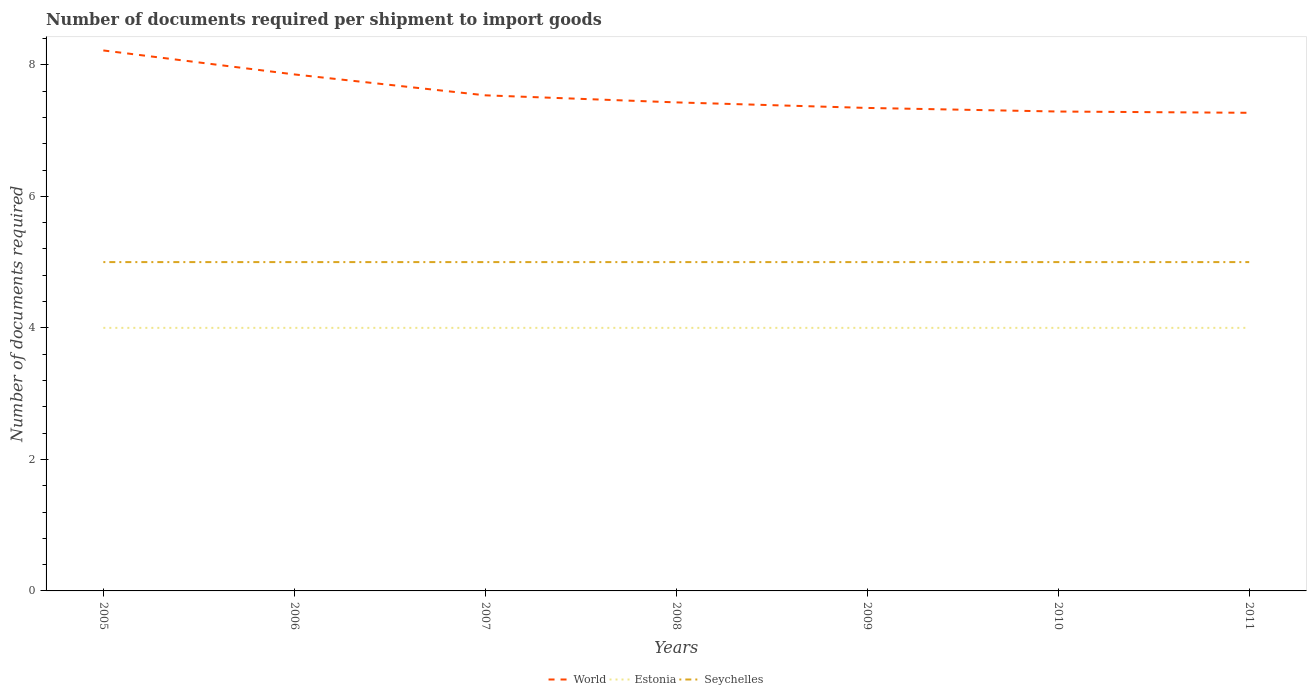How many different coloured lines are there?
Provide a short and direct response. 3. Is the number of lines equal to the number of legend labels?
Your response must be concise. Yes. Across all years, what is the maximum number of documents required per shipment to import goods in World?
Provide a short and direct response. 7.27. What is the difference between the highest and the second highest number of documents required per shipment to import goods in Estonia?
Your answer should be compact. 0. Is the number of documents required per shipment to import goods in World strictly greater than the number of documents required per shipment to import goods in Estonia over the years?
Provide a short and direct response. No. How many lines are there?
Provide a succinct answer. 3. Are the values on the major ticks of Y-axis written in scientific E-notation?
Give a very brief answer. No. Does the graph contain grids?
Keep it short and to the point. No. Where does the legend appear in the graph?
Give a very brief answer. Bottom center. How are the legend labels stacked?
Provide a short and direct response. Horizontal. What is the title of the graph?
Provide a short and direct response. Number of documents required per shipment to import goods. What is the label or title of the Y-axis?
Your response must be concise. Number of documents required. What is the Number of documents required of World in 2005?
Your response must be concise. 8.22. What is the Number of documents required in Estonia in 2005?
Keep it short and to the point. 4. What is the Number of documents required of World in 2006?
Offer a terse response. 7.85. What is the Number of documents required of Estonia in 2006?
Your answer should be compact. 4. What is the Number of documents required in Seychelles in 2006?
Your response must be concise. 5. What is the Number of documents required of World in 2007?
Your response must be concise. 7.54. What is the Number of documents required of Seychelles in 2007?
Your response must be concise. 5. What is the Number of documents required of World in 2008?
Keep it short and to the point. 7.43. What is the Number of documents required of Seychelles in 2008?
Ensure brevity in your answer.  5. What is the Number of documents required of World in 2009?
Your answer should be compact. 7.34. What is the Number of documents required of Estonia in 2009?
Ensure brevity in your answer.  4. What is the Number of documents required of World in 2010?
Your response must be concise. 7.29. What is the Number of documents required of Estonia in 2010?
Your answer should be very brief. 4. What is the Number of documents required of Seychelles in 2010?
Provide a short and direct response. 5. What is the Number of documents required of World in 2011?
Ensure brevity in your answer.  7.27. What is the Number of documents required in Estonia in 2011?
Your response must be concise. 4. Across all years, what is the maximum Number of documents required in World?
Your response must be concise. 8.22. Across all years, what is the maximum Number of documents required in Estonia?
Provide a short and direct response. 4. Across all years, what is the minimum Number of documents required of World?
Your response must be concise. 7.27. Across all years, what is the minimum Number of documents required of Estonia?
Offer a very short reply. 4. Across all years, what is the minimum Number of documents required of Seychelles?
Your answer should be very brief. 5. What is the total Number of documents required in World in the graph?
Offer a very short reply. 52.94. What is the total Number of documents required of Estonia in the graph?
Your response must be concise. 28. What is the total Number of documents required in Seychelles in the graph?
Your answer should be very brief. 35. What is the difference between the Number of documents required in World in 2005 and that in 2006?
Your answer should be compact. 0.36. What is the difference between the Number of documents required of Estonia in 2005 and that in 2006?
Provide a succinct answer. 0. What is the difference between the Number of documents required of Seychelles in 2005 and that in 2006?
Provide a short and direct response. 0. What is the difference between the Number of documents required of World in 2005 and that in 2007?
Your response must be concise. 0.68. What is the difference between the Number of documents required of Seychelles in 2005 and that in 2007?
Provide a succinct answer. 0. What is the difference between the Number of documents required in World in 2005 and that in 2008?
Offer a terse response. 0.79. What is the difference between the Number of documents required in Seychelles in 2005 and that in 2008?
Offer a terse response. 0. What is the difference between the Number of documents required in World in 2005 and that in 2009?
Give a very brief answer. 0.87. What is the difference between the Number of documents required in Estonia in 2005 and that in 2009?
Give a very brief answer. 0. What is the difference between the Number of documents required of World in 2005 and that in 2010?
Offer a very short reply. 0.93. What is the difference between the Number of documents required in Estonia in 2005 and that in 2010?
Give a very brief answer. 0. What is the difference between the Number of documents required of World in 2005 and that in 2011?
Keep it short and to the point. 0.95. What is the difference between the Number of documents required in Estonia in 2005 and that in 2011?
Ensure brevity in your answer.  0. What is the difference between the Number of documents required in World in 2006 and that in 2007?
Keep it short and to the point. 0.32. What is the difference between the Number of documents required in Estonia in 2006 and that in 2007?
Give a very brief answer. 0. What is the difference between the Number of documents required of World in 2006 and that in 2008?
Your response must be concise. 0.43. What is the difference between the Number of documents required of Estonia in 2006 and that in 2008?
Provide a short and direct response. 0. What is the difference between the Number of documents required of Seychelles in 2006 and that in 2008?
Your answer should be compact. 0. What is the difference between the Number of documents required of World in 2006 and that in 2009?
Ensure brevity in your answer.  0.51. What is the difference between the Number of documents required of Seychelles in 2006 and that in 2009?
Your answer should be very brief. 0. What is the difference between the Number of documents required in World in 2006 and that in 2010?
Make the answer very short. 0.56. What is the difference between the Number of documents required of Estonia in 2006 and that in 2010?
Your answer should be compact. 0. What is the difference between the Number of documents required in Seychelles in 2006 and that in 2010?
Your answer should be compact. 0. What is the difference between the Number of documents required in World in 2006 and that in 2011?
Your answer should be compact. 0.58. What is the difference between the Number of documents required of Seychelles in 2006 and that in 2011?
Offer a very short reply. 0. What is the difference between the Number of documents required in World in 2007 and that in 2008?
Ensure brevity in your answer.  0.11. What is the difference between the Number of documents required of Seychelles in 2007 and that in 2008?
Keep it short and to the point. 0. What is the difference between the Number of documents required in World in 2007 and that in 2009?
Offer a terse response. 0.19. What is the difference between the Number of documents required of World in 2007 and that in 2010?
Make the answer very short. 0.25. What is the difference between the Number of documents required in Estonia in 2007 and that in 2010?
Offer a very short reply. 0. What is the difference between the Number of documents required in World in 2007 and that in 2011?
Make the answer very short. 0.27. What is the difference between the Number of documents required in World in 2008 and that in 2009?
Offer a terse response. 0.08. What is the difference between the Number of documents required in Seychelles in 2008 and that in 2009?
Offer a very short reply. 0. What is the difference between the Number of documents required in World in 2008 and that in 2010?
Give a very brief answer. 0.14. What is the difference between the Number of documents required of Seychelles in 2008 and that in 2010?
Offer a terse response. 0. What is the difference between the Number of documents required in World in 2008 and that in 2011?
Offer a very short reply. 0.16. What is the difference between the Number of documents required in Seychelles in 2008 and that in 2011?
Provide a short and direct response. 0. What is the difference between the Number of documents required of World in 2009 and that in 2010?
Your answer should be very brief. 0.05. What is the difference between the Number of documents required in Seychelles in 2009 and that in 2010?
Give a very brief answer. 0. What is the difference between the Number of documents required of World in 2009 and that in 2011?
Provide a succinct answer. 0.07. What is the difference between the Number of documents required in World in 2010 and that in 2011?
Your answer should be very brief. 0.02. What is the difference between the Number of documents required in Estonia in 2010 and that in 2011?
Offer a very short reply. 0. What is the difference between the Number of documents required in World in 2005 and the Number of documents required in Estonia in 2006?
Offer a very short reply. 4.22. What is the difference between the Number of documents required in World in 2005 and the Number of documents required in Seychelles in 2006?
Your answer should be very brief. 3.22. What is the difference between the Number of documents required in Estonia in 2005 and the Number of documents required in Seychelles in 2006?
Provide a short and direct response. -1. What is the difference between the Number of documents required in World in 2005 and the Number of documents required in Estonia in 2007?
Provide a short and direct response. 4.22. What is the difference between the Number of documents required in World in 2005 and the Number of documents required in Seychelles in 2007?
Make the answer very short. 3.22. What is the difference between the Number of documents required in Estonia in 2005 and the Number of documents required in Seychelles in 2007?
Your answer should be compact. -1. What is the difference between the Number of documents required in World in 2005 and the Number of documents required in Estonia in 2008?
Ensure brevity in your answer.  4.22. What is the difference between the Number of documents required of World in 2005 and the Number of documents required of Seychelles in 2008?
Offer a terse response. 3.22. What is the difference between the Number of documents required in Estonia in 2005 and the Number of documents required in Seychelles in 2008?
Your answer should be very brief. -1. What is the difference between the Number of documents required of World in 2005 and the Number of documents required of Estonia in 2009?
Your answer should be very brief. 4.22. What is the difference between the Number of documents required of World in 2005 and the Number of documents required of Seychelles in 2009?
Your answer should be compact. 3.22. What is the difference between the Number of documents required in Estonia in 2005 and the Number of documents required in Seychelles in 2009?
Give a very brief answer. -1. What is the difference between the Number of documents required of World in 2005 and the Number of documents required of Estonia in 2010?
Keep it short and to the point. 4.22. What is the difference between the Number of documents required of World in 2005 and the Number of documents required of Seychelles in 2010?
Your response must be concise. 3.22. What is the difference between the Number of documents required of World in 2005 and the Number of documents required of Estonia in 2011?
Your response must be concise. 4.22. What is the difference between the Number of documents required of World in 2005 and the Number of documents required of Seychelles in 2011?
Your response must be concise. 3.22. What is the difference between the Number of documents required in Estonia in 2005 and the Number of documents required in Seychelles in 2011?
Provide a succinct answer. -1. What is the difference between the Number of documents required of World in 2006 and the Number of documents required of Estonia in 2007?
Make the answer very short. 3.85. What is the difference between the Number of documents required in World in 2006 and the Number of documents required in Seychelles in 2007?
Give a very brief answer. 2.85. What is the difference between the Number of documents required of Estonia in 2006 and the Number of documents required of Seychelles in 2007?
Offer a terse response. -1. What is the difference between the Number of documents required of World in 2006 and the Number of documents required of Estonia in 2008?
Provide a succinct answer. 3.85. What is the difference between the Number of documents required in World in 2006 and the Number of documents required in Seychelles in 2008?
Provide a succinct answer. 2.85. What is the difference between the Number of documents required in World in 2006 and the Number of documents required in Estonia in 2009?
Provide a short and direct response. 3.85. What is the difference between the Number of documents required in World in 2006 and the Number of documents required in Seychelles in 2009?
Your response must be concise. 2.85. What is the difference between the Number of documents required in World in 2006 and the Number of documents required in Estonia in 2010?
Ensure brevity in your answer.  3.85. What is the difference between the Number of documents required in World in 2006 and the Number of documents required in Seychelles in 2010?
Your response must be concise. 2.85. What is the difference between the Number of documents required of World in 2006 and the Number of documents required of Estonia in 2011?
Keep it short and to the point. 3.85. What is the difference between the Number of documents required of World in 2006 and the Number of documents required of Seychelles in 2011?
Offer a terse response. 2.85. What is the difference between the Number of documents required of Estonia in 2006 and the Number of documents required of Seychelles in 2011?
Your answer should be very brief. -1. What is the difference between the Number of documents required of World in 2007 and the Number of documents required of Estonia in 2008?
Ensure brevity in your answer.  3.54. What is the difference between the Number of documents required in World in 2007 and the Number of documents required in Seychelles in 2008?
Your answer should be very brief. 2.54. What is the difference between the Number of documents required of World in 2007 and the Number of documents required of Estonia in 2009?
Your answer should be very brief. 3.54. What is the difference between the Number of documents required of World in 2007 and the Number of documents required of Seychelles in 2009?
Make the answer very short. 2.54. What is the difference between the Number of documents required in Estonia in 2007 and the Number of documents required in Seychelles in 2009?
Your response must be concise. -1. What is the difference between the Number of documents required in World in 2007 and the Number of documents required in Estonia in 2010?
Offer a very short reply. 3.54. What is the difference between the Number of documents required in World in 2007 and the Number of documents required in Seychelles in 2010?
Ensure brevity in your answer.  2.54. What is the difference between the Number of documents required of World in 2007 and the Number of documents required of Estonia in 2011?
Offer a terse response. 3.54. What is the difference between the Number of documents required in World in 2007 and the Number of documents required in Seychelles in 2011?
Ensure brevity in your answer.  2.54. What is the difference between the Number of documents required in World in 2008 and the Number of documents required in Estonia in 2009?
Give a very brief answer. 3.43. What is the difference between the Number of documents required of World in 2008 and the Number of documents required of Seychelles in 2009?
Give a very brief answer. 2.43. What is the difference between the Number of documents required of Estonia in 2008 and the Number of documents required of Seychelles in 2009?
Your answer should be very brief. -1. What is the difference between the Number of documents required of World in 2008 and the Number of documents required of Estonia in 2010?
Provide a succinct answer. 3.43. What is the difference between the Number of documents required of World in 2008 and the Number of documents required of Seychelles in 2010?
Provide a short and direct response. 2.43. What is the difference between the Number of documents required of World in 2008 and the Number of documents required of Estonia in 2011?
Provide a short and direct response. 3.43. What is the difference between the Number of documents required of World in 2008 and the Number of documents required of Seychelles in 2011?
Ensure brevity in your answer.  2.43. What is the difference between the Number of documents required in Estonia in 2008 and the Number of documents required in Seychelles in 2011?
Provide a succinct answer. -1. What is the difference between the Number of documents required of World in 2009 and the Number of documents required of Estonia in 2010?
Your answer should be compact. 3.34. What is the difference between the Number of documents required in World in 2009 and the Number of documents required in Seychelles in 2010?
Give a very brief answer. 2.34. What is the difference between the Number of documents required in World in 2009 and the Number of documents required in Estonia in 2011?
Your response must be concise. 3.34. What is the difference between the Number of documents required of World in 2009 and the Number of documents required of Seychelles in 2011?
Keep it short and to the point. 2.34. What is the difference between the Number of documents required in World in 2010 and the Number of documents required in Estonia in 2011?
Your answer should be very brief. 3.29. What is the difference between the Number of documents required of World in 2010 and the Number of documents required of Seychelles in 2011?
Offer a very short reply. 2.29. What is the difference between the Number of documents required in Estonia in 2010 and the Number of documents required in Seychelles in 2011?
Keep it short and to the point. -1. What is the average Number of documents required of World per year?
Ensure brevity in your answer.  7.56. What is the average Number of documents required in Estonia per year?
Provide a succinct answer. 4. In the year 2005, what is the difference between the Number of documents required of World and Number of documents required of Estonia?
Your answer should be compact. 4.22. In the year 2005, what is the difference between the Number of documents required of World and Number of documents required of Seychelles?
Provide a succinct answer. 3.22. In the year 2005, what is the difference between the Number of documents required of Estonia and Number of documents required of Seychelles?
Provide a short and direct response. -1. In the year 2006, what is the difference between the Number of documents required of World and Number of documents required of Estonia?
Offer a terse response. 3.85. In the year 2006, what is the difference between the Number of documents required in World and Number of documents required in Seychelles?
Your response must be concise. 2.85. In the year 2006, what is the difference between the Number of documents required of Estonia and Number of documents required of Seychelles?
Ensure brevity in your answer.  -1. In the year 2007, what is the difference between the Number of documents required of World and Number of documents required of Estonia?
Make the answer very short. 3.54. In the year 2007, what is the difference between the Number of documents required in World and Number of documents required in Seychelles?
Your response must be concise. 2.54. In the year 2007, what is the difference between the Number of documents required of Estonia and Number of documents required of Seychelles?
Your response must be concise. -1. In the year 2008, what is the difference between the Number of documents required of World and Number of documents required of Estonia?
Provide a short and direct response. 3.43. In the year 2008, what is the difference between the Number of documents required of World and Number of documents required of Seychelles?
Provide a succinct answer. 2.43. In the year 2008, what is the difference between the Number of documents required of Estonia and Number of documents required of Seychelles?
Keep it short and to the point. -1. In the year 2009, what is the difference between the Number of documents required of World and Number of documents required of Estonia?
Your response must be concise. 3.34. In the year 2009, what is the difference between the Number of documents required in World and Number of documents required in Seychelles?
Give a very brief answer. 2.34. In the year 2009, what is the difference between the Number of documents required in Estonia and Number of documents required in Seychelles?
Make the answer very short. -1. In the year 2010, what is the difference between the Number of documents required of World and Number of documents required of Estonia?
Provide a short and direct response. 3.29. In the year 2010, what is the difference between the Number of documents required in World and Number of documents required in Seychelles?
Offer a terse response. 2.29. In the year 2010, what is the difference between the Number of documents required of Estonia and Number of documents required of Seychelles?
Ensure brevity in your answer.  -1. In the year 2011, what is the difference between the Number of documents required in World and Number of documents required in Estonia?
Offer a very short reply. 3.27. In the year 2011, what is the difference between the Number of documents required of World and Number of documents required of Seychelles?
Give a very brief answer. 2.27. In the year 2011, what is the difference between the Number of documents required of Estonia and Number of documents required of Seychelles?
Provide a succinct answer. -1. What is the ratio of the Number of documents required of World in 2005 to that in 2006?
Your answer should be compact. 1.05. What is the ratio of the Number of documents required of Estonia in 2005 to that in 2006?
Ensure brevity in your answer.  1. What is the ratio of the Number of documents required in World in 2005 to that in 2007?
Offer a very short reply. 1.09. What is the ratio of the Number of documents required of World in 2005 to that in 2008?
Provide a succinct answer. 1.11. What is the ratio of the Number of documents required in Seychelles in 2005 to that in 2008?
Ensure brevity in your answer.  1. What is the ratio of the Number of documents required of World in 2005 to that in 2009?
Ensure brevity in your answer.  1.12. What is the ratio of the Number of documents required of Estonia in 2005 to that in 2009?
Your answer should be very brief. 1. What is the ratio of the Number of documents required of Seychelles in 2005 to that in 2009?
Ensure brevity in your answer.  1. What is the ratio of the Number of documents required of World in 2005 to that in 2010?
Provide a short and direct response. 1.13. What is the ratio of the Number of documents required in World in 2005 to that in 2011?
Your answer should be very brief. 1.13. What is the ratio of the Number of documents required of Estonia in 2005 to that in 2011?
Your answer should be compact. 1. What is the ratio of the Number of documents required in World in 2006 to that in 2007?
Your response must be concise. 1.04. What is the ratio of the Number of documents required of Seychelles in 2006 to that in 2007?
Your response must be concise. 1. What is the ratio of the Number of documents required in World in 2006 to that in 2008?
Provide a succinct answer. 1.06. What is the ratio of the Number of documents required of Estonia in 2006 to that in 2008?
Give a very brief answer. 1. What is the ratio of the Number of documents required of World in 2006 to that in 2009?
Your answer should be compact. 1.07. What is the ratio of the Number of documents required in World in 2006 to that in 2010?
Make the answer very short. 1.08. What is the ratio of the Number of documents required in Estonia in 2006 to that in 2010?
Offer a very short reply. 1. What is the ratio of the Number of documents required in World in 2006 to that in 2011?
Ensure brevity in your answer.  1.08. What is the ratio of the Number of documents required in Estonia in 2006 to that in 2011?
Give a very brief answer. 1. What is the ratio of the Number of documents required of Seychelles in 2006 to that in 2011?
Provide a succinct answer. 1. What is the ratio of the Number of documents required of World in 2007 to that in 2008?
Your answer should be compact. 1.01. What is the ratio of the Number of documents required of World in 2007 to that in 2009?
Keep it short and to the point. 1.03. What is the ratio of the Number of documents required in Seychelles in 2007 to that in 2009?
Offer a very short reply. 1. What is the ratio of the Number of documents required in World in 2007 to that in 2010?
Ensure brevity in your answer.  1.03. What is the ratio of the Number of documents required in Estonia in 2007 to that in 2010?
Give a very brief answer. 1. What is the ratio of the Number of documents required in World in 2007 to that in 2011?
Offer a terse response. 1.04. What is the ratio of the Number of documents required of Estonia in 2007 to that in 2011?
Provide a short and direct response. 1. What is the ratio of the Number of documents required of Seychelles in 2007 to that in 2011?
Your response must be concise. 1. What is the ratio of the Number of documents required of World in 2008 to that in 2009?
Offer a very short reply. 1.01. What is the ratio of the Number of documents required in Estonia in 2008 to that in 2009?
Give a very brief answer. 1. What is the ratio of the Number of documents required of World in 2008 to that in 2010?
Provide a succinct answer. 1.02. What is the ratio of the Number of documents required of Estonia in 2008 to that in 2010?
Give a very brief answer. 1. What is the ratio of the Number of documents required in World in 2008 to that in 2011?
Offer a terse response. 1.02. What is the ratio of the Number of documents required in World in 2009 to that in 2010?
Offer a very short reply. 1.01. What is the ratio of the Number of documents required of Estonia in 2009 to that in 2010?
Your answer should be very brief. 1. What is the ratio of the Number of documents required in Seychelles in 2009 to that in 2010?
Offer a very short reply. 1. What is the ratio of the Number of documents required in World in 2009 to that in 2011?
Your answer should be compact. 1.01. What is the ratio of the Number of documents required in Estonia in 2009 to that in 2011?
Your answer should be compact. 1. What is the ratio of the Number of documents required of Seychelles in 2009 to that in 2011?
Keep it short and to the point. 1. What is the difference between the highest and the second highest Number of documents required of World?
Make the answer very short. 0.36. What is the difference between the highest and the lowest Number of documents required of World?
Your answer should be very brief. 0.95. What is the difference between the highest and the lowest Number of documents required of Estonia?
Your response must be concise. 0. 